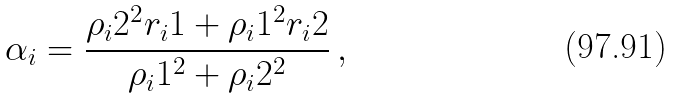<formula> <loc_0><loc_0><loc_500><loc_500>\alpha _ { i } = \frac { \rho _ { i } 2 ^ { 2 } r _ { i } 1 + \rho _ { i } 1 ^ { 2 } r _ { i } 2 } { \rho _ { i } 1 ^ { 2 } + \rho _ { i } 2 ^ { 2 } } \, ,</formula> 